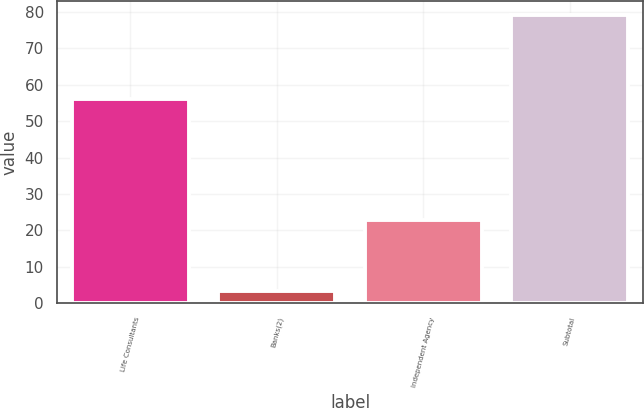<chart> <loc_0><loc_0><loc_500><loc_500><bar_chart><fcel>Life Consultants<fcel>Banks(2)<fcel>Independent Agency<fcel>Subtotal<nl><fcel>56<fcel>3.34<fcel>23<fcel>79<nl></chart> 